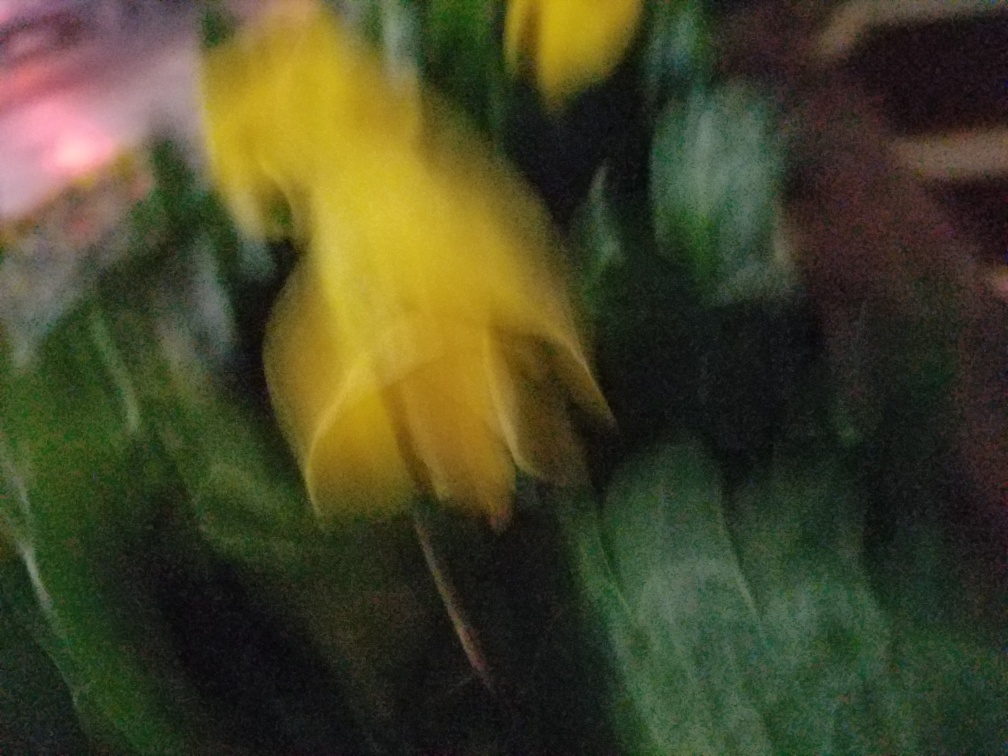Is there anything that can be done to improve the clarity of an image like this after it has been taken? Once a photo is taken with this degree of blur, it's difficult to recover the lost details. However, some post-processing techniques, such as sharpening filters or deblurring tools, might slightly enhance the image, albeit with limited success. For significant improvements, re-taking the photograph under better conditions is recommended. 